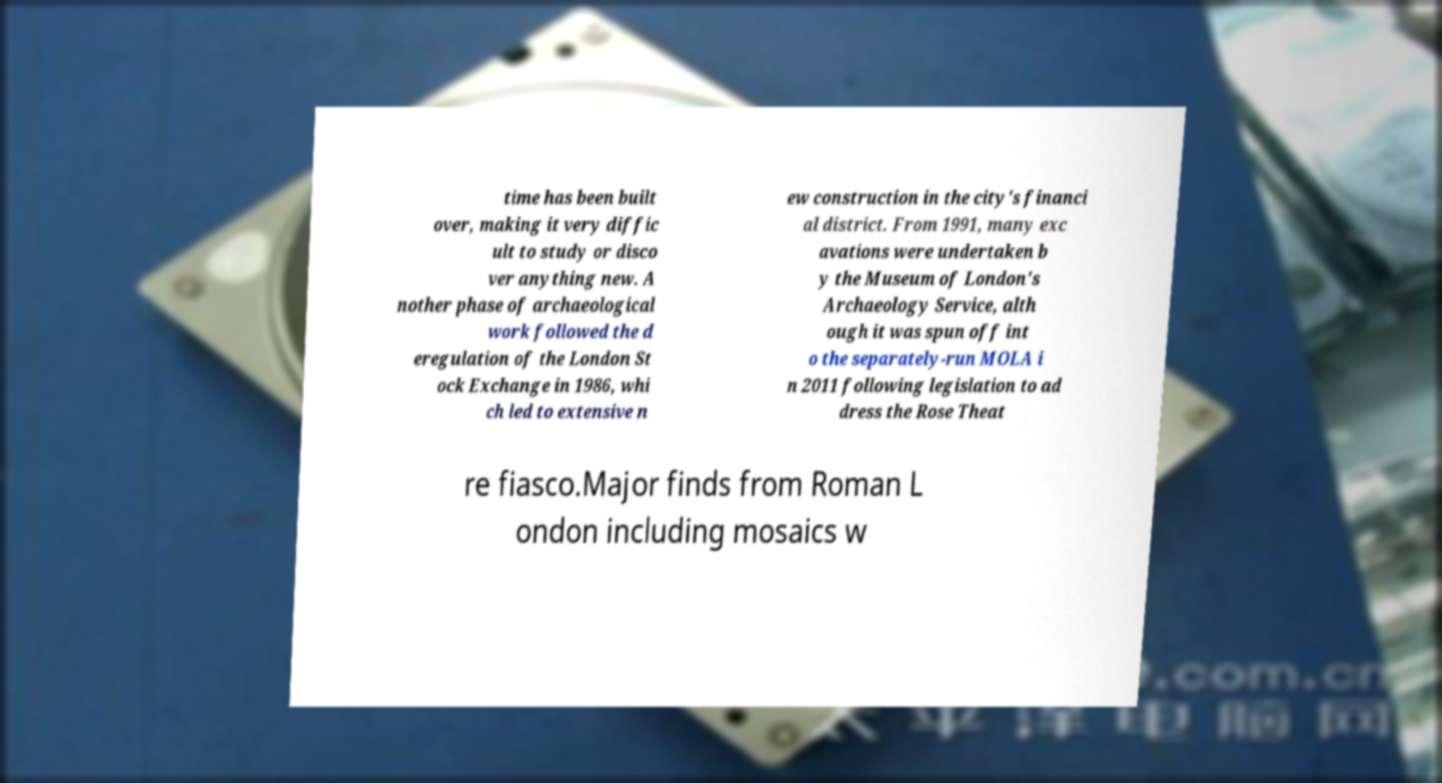Could you extract and type out the text from this image? time has been built over, making it very diffic ult to study or disco ver anything new. A nother phase of archaeological work followed the d eregulation of the London St ock Exchange in 1986, whi ch led to extensive n ew construction in the city's financi al district. From 1991, many exc avations were undertaken b y the Museum of London's Archaeology Service, alth ough it was spun off int o the separately-run MOLA i n 2011 following legislation to ad dress the Rose Theat re fiasco.Major finds from Roman L ondon including mosaics w 